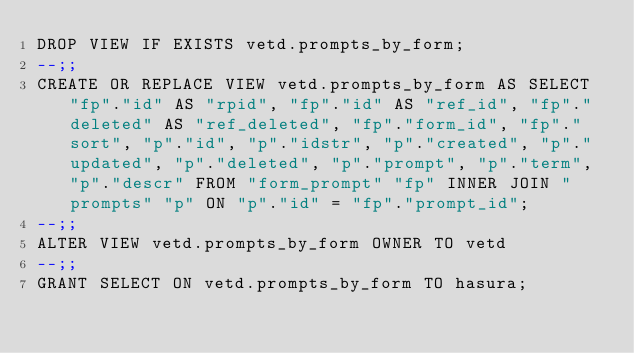<code> <loc_0><loc_0><loc_500><loc_500><_SQL_>DROP VIEW IF EXISTS vetd.prompts_by_form;
--;;
CREATE OR REPLACE VIEW vetd.prompts_by_form AS SELECT "fp"."id" AS "rpid", "fp"."id" AS "ref_id", "fp"."deleted" AS "ref_deleted", "fp"."form_id", "fp"."sort", "p"."id", "p"."idstr", "p"."created", "p"."updated", "p"."deleted", "p"."prompt", "p"."term", "p"."descr" FROM "form_prompt" "fp" INNER JOIN "prompts" "p" ON "p"."id" = "fp"."prompt_id";
--;;
ALTER VIEW vetd.prompts_by_form OWNER TO vetd
--;;
GRANT SELECT ON vetd.prompts_by_form TO hasura;</code> 